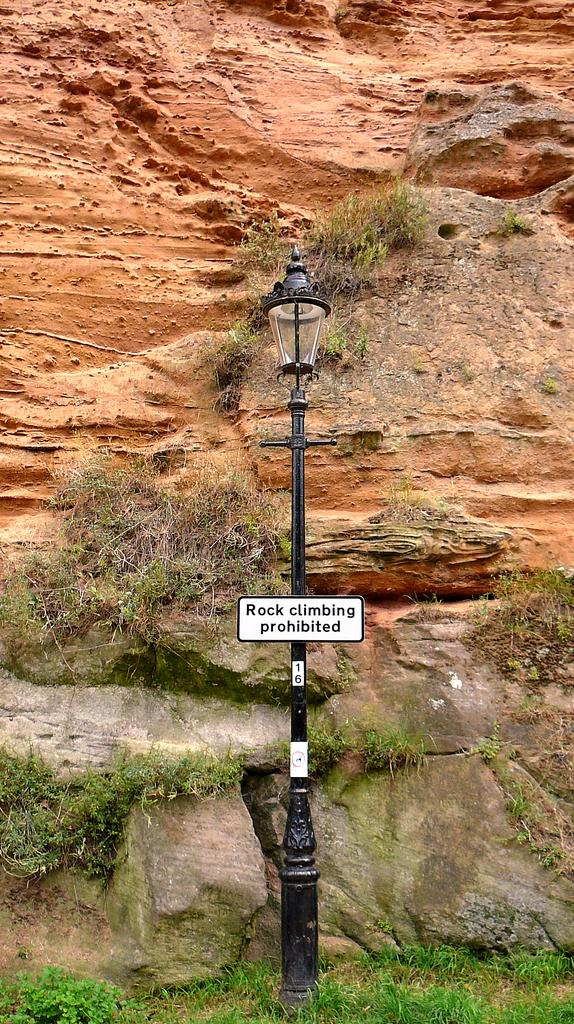What is attached to the light pole in the image? There is a board attached to a light pole in the image. What can be seen in the background of the image? There is a rock and grass visible in the background of the image. What type of pocket can be seen on the queen in the image? There is no queen or pocket present in the image. 